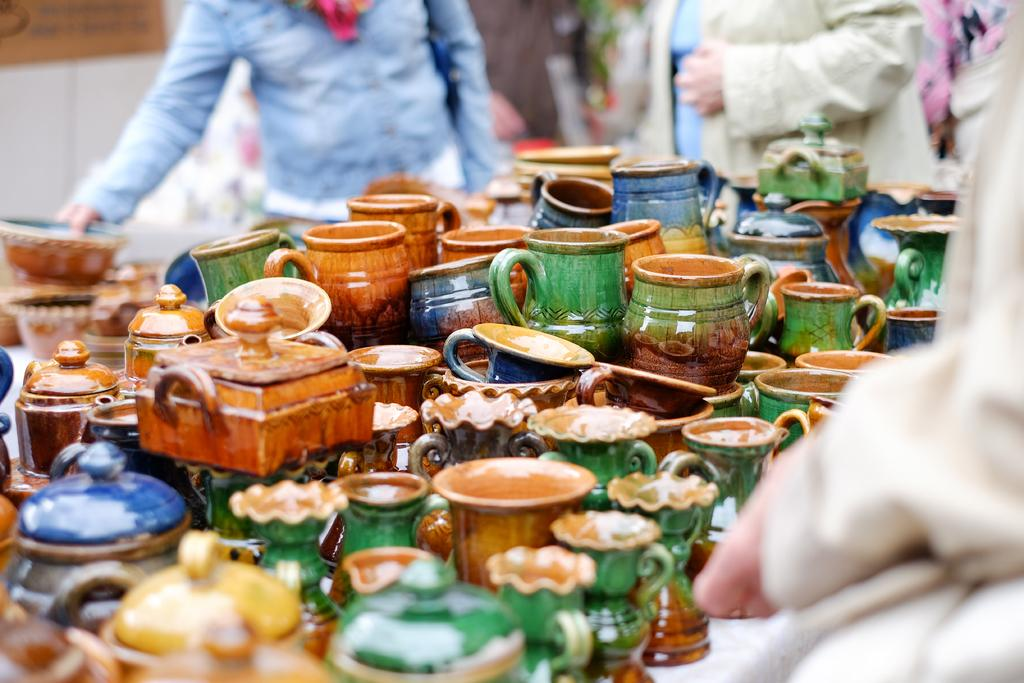What type of objects can be seen in the image? There is a group of objects that resemble porcelain utensils in the image. Are there any living beings visible in the image? Yes, there are people visible in the image. What is located in the top left corner of the image? There is a wall with a board in the top left corner of the image. How many friends are visible in the image? There is no mention of friends in the image, as the provided facts only mention the presence of people. 